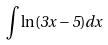<formula> <loc_0><loc_0><loc_500><loc_500>\int \ln ( 3 x - 5 ) d x</formula> 